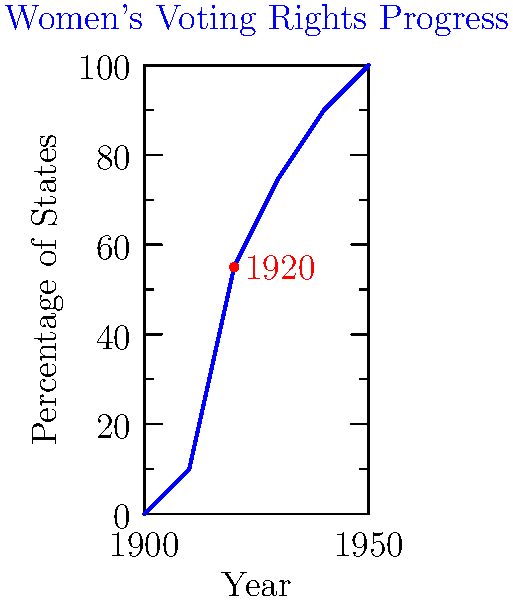Based on the graph showing the progress of women's voting rights across U.S. states, approximately what percentage of states had granted women the right to vote by 1920, the year the 19th Amendment was ratified? To determine the percentage of states that had granted women the right to vote by 1920, we need to follow these steps:

1. Locate the year 1920 on the x-axis of the graph.
2. Find the corresponding point on the blue line representing the progress of women's voting rights.
3. Read the percentage value on the y-axis that aligns with this point.

Looking at the graph:
1. We can see that 1920 is marked on the x-axis.
2. There is a red dot on the blue line corresponding to 1920.
3. Following this point horizontally to the y-axis, we can see it aligns with approximately 55%.

This percentage makes sense historically, as 1920 was the year the 19th Amendment was ratified, granting women the right to vote nationwide. Before this, individual states had been gradually granting women voting rights, with about half of the states having done so by 1920.
Answer: 55% 